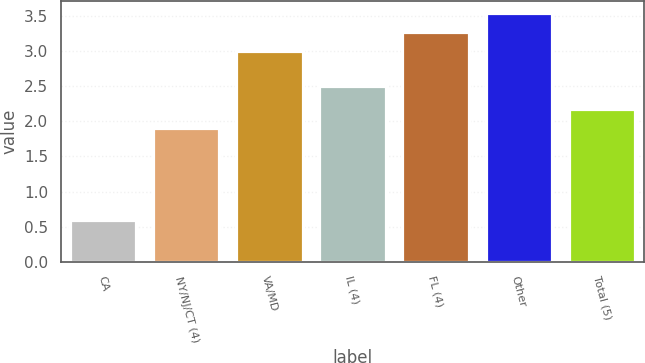Convert chart to OTSL. <chart><loc_0><loc_0><loc_500><loc_500><bar_chart><fcel>CA<fcel>NY/NJ/CT (4)<fcel>VA/MD<fcel>IL (4)<fcel>FL (4)<fcel>Other<fcel>Total (5)<nl><fcel>0.6<fcel>1.9<fcel>3<fcel>2.5<fcel>3.27<fcel>3.54<fcel>2.17<nl></chart> 